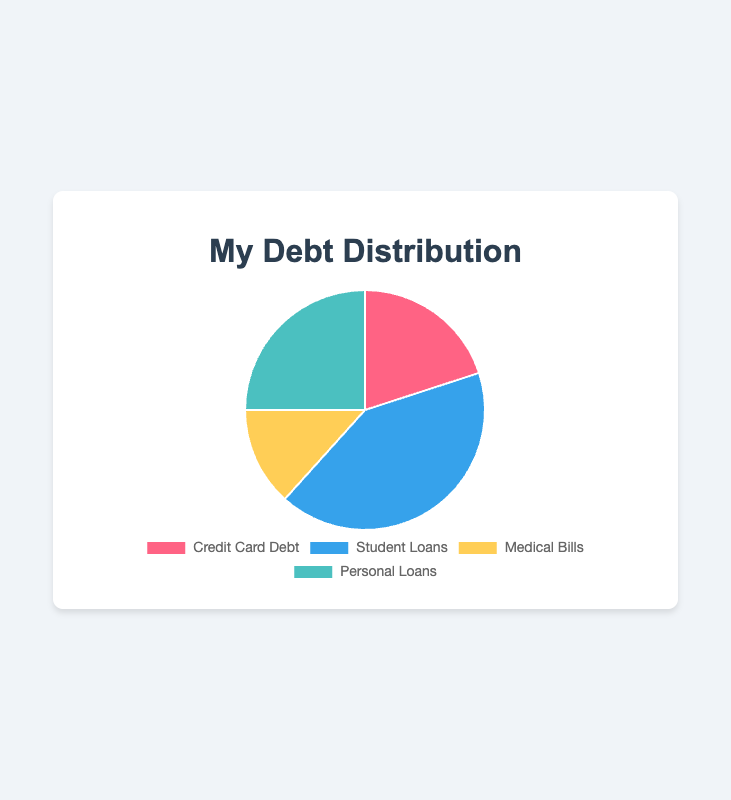What percentage of the total debt does Credit Card Debt represent? First, calculate the total debt amount: $1200 (Credit Card Debt) + $2500 (Student Loans) + $800 (Medical Bills) + $1500 (Personal Loans) = $6000. Then, divide the Credit Card Debt by the total debt and multiply by 100 to get the percentage: ($1200 / $6000) * 100 ≈ 20%
Answer: 20% How much more debt do Student Loans represent compared to Medical Bills? Subtract the amount of Medical Bills from the amount of Student Loans: $2500 (Student Loans) - $800 (Medical Bills) = $1700.
Answer: $1700 What is the total amount of debt from Personal Loans and Medical Bills combined? Add the amounts of Personal Loans and Medical Bills: $1500 (Personal Loans) + $800 (Medical Bills) = $2300
Answer: $2300 Which debt category is the largest? Compare the amounts for each debt category: $1200 (Credit Card Debt), $2500 (Student Loans), $800 (Medical Bills), $1500 (Personal Loans). Student Loans have the highest amount at $2500.
Answer: Student Loans What fraction of the total debt is comprised of Medical Bills? Calculate the total debt amount: $1200 (Credit Card Debt) + $2500 (Student Loans) + $800 (Medical Bills) + $1500 (Personal Loans) = $6000. Then, divide Medical Bills by the total debt: $800 / $6000 = 1/7.5, which can be simplified to 8/60 or 2/15.
Answer: 2/15 How many times larger are Personal Loans compared to Medical Bills? Calculate the ratio by dividing the amount of Personal Loans by the amount of Medical Bills: $1500 / $800 = 1.875
Answer: 1.875 times If you paid off half of your Credit Card Debt, what would the new amount be? Divide the Credit Card Debt by 2: $1200 / 2 = $600. Subtract this from the original amount: $1200 - $600 = $600
Answer: $600 What is the average amount of debt across all categories? Calculate the total debt amount: $1200 (Credit Card Debt) + $2500 (Student Loans) + $800 (Medical Bills) + $1500 (Personal Loans) = $6000. Then, divide by the number of categories (4): $6000 / 4 = $1500
Answer: $1500 